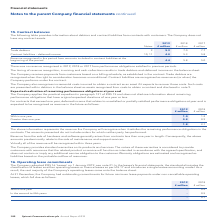According to Spirent Communications Plc's financial document, For contracts that exceed one year, what is expected to be recognised as revenue in the future? deferred income that relates to unsatisfied or partially satisfied performance obligations at year end. The document states: "For contracts that exceed one year, deferred income that relates to unsatisfied or partially satisfied performance obligations at year end is expected..." Also, What generally arises from contracts less than one year in length? Revenue from the sale of hardware and software. The document states: "Revenue from the sale of hardware and software generally arises from contracts less than one year in length. Consequently, the above amounts predo..." Also, What are the types of contracts in the table for which the Company will recognise their revenue when it satisfies the remaining performance obligations in the contracts? The document shows two values: Within one year and Greater than one year. From the document: "Within one year 1.0 1.2 Greater than one year 0.8 0.9..." Additionally, In which year was the amount within one year larger? According to the financial document, 2018. The relevant text states: "2018 £ million 2017 £ million..." Also, can you calculate: What was the change in the amount within one year between 2018 and 2019? Based on the calculation: 1.0-1.2, the result is -0.2 (in millions). This is based on the information: "Within one year 1.0 1.2 Within one year 1.0 1.2..." The key data points involved are: 1.0, 1.2. Also, can you calculate: What was the percentage change in the amount within one year? To answer this question, I need to perform calculations using the financial data. The calculation is: (1.0-1.2)/1.2, which equals -16.67 (percentage). This is based on the information: "Within one year 1.0 1.2 Within one year 1.0 1.2..." The key data points involved are: 1.0, 1.2. 